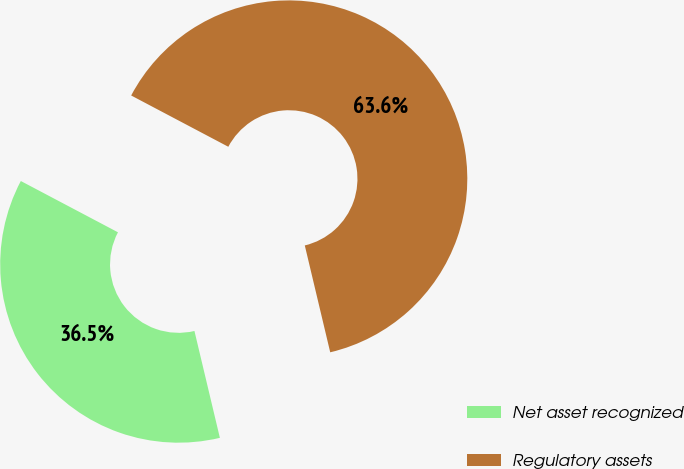Convert chart. <chart><loc_0><loc_0><loc_500><loc_500><pie_chart><fcel>Net asset recognized<fcel>Regulatory assets<nl><fcel>36.45%<fcel>63.55%<nl></chart> 